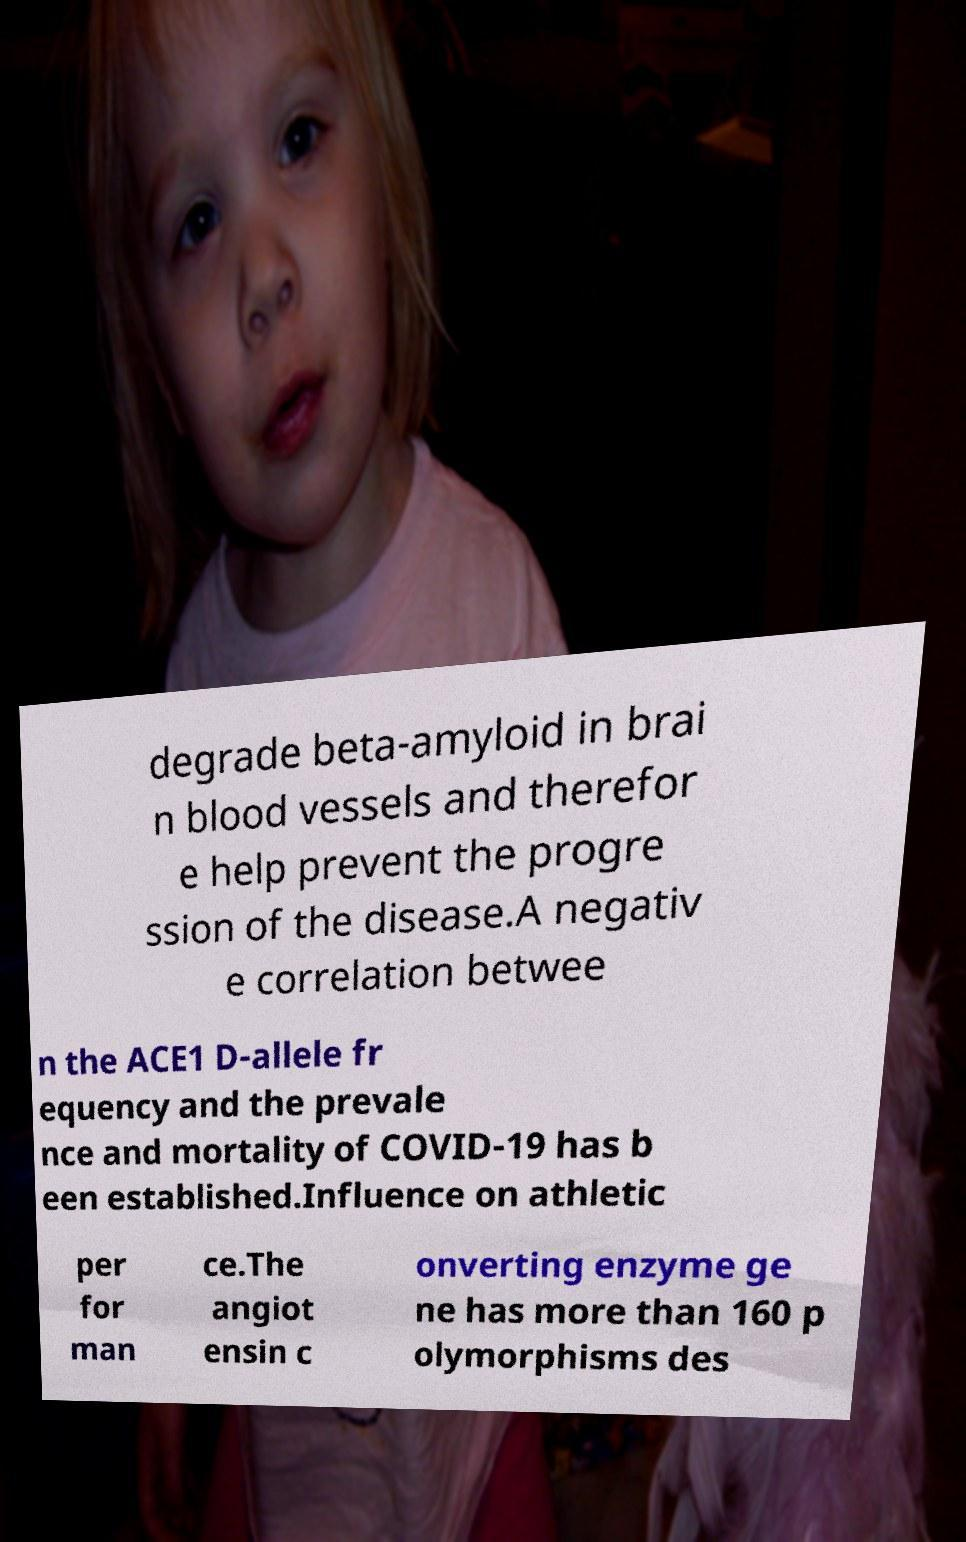Could you extract and type out the text from this image? degrade beta-amyloid in brai n blood vessels and therefor e help prevent the progre ssion of the disease.A negativ e correlation betwee n the ACE1 D-allele fr equency and the prevale nce and mortality of COVID-19 has b een established.Influence on athletic per for man ce.The angiot ensin c onverting enzyme ge ne has more than 160 p olymorphisms des 